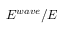<formula> <loc_0><loc_0><loc_500><loc_500>E ^ { w a v e } / E</formula> 